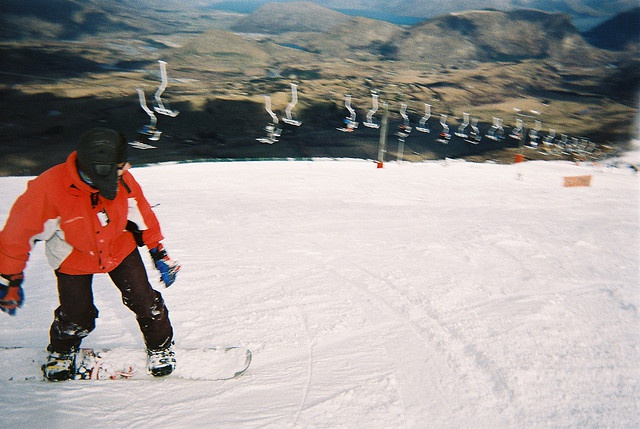Describe the objects in this image and their specific colors. I can see people in black, brown, and lightgray tones and snowboard in black, lightgray, darkgray, and tan tones in this image. 